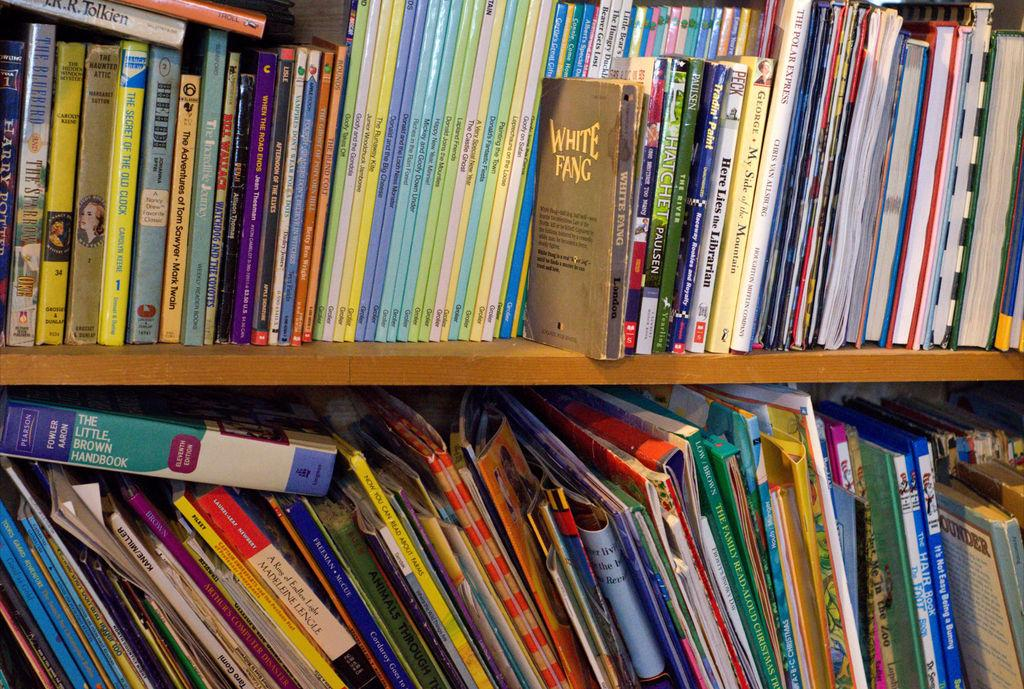<image>
Render a clear and concise summary of the photo. A bookshelf over flowing with books from early readers to chapter books. 